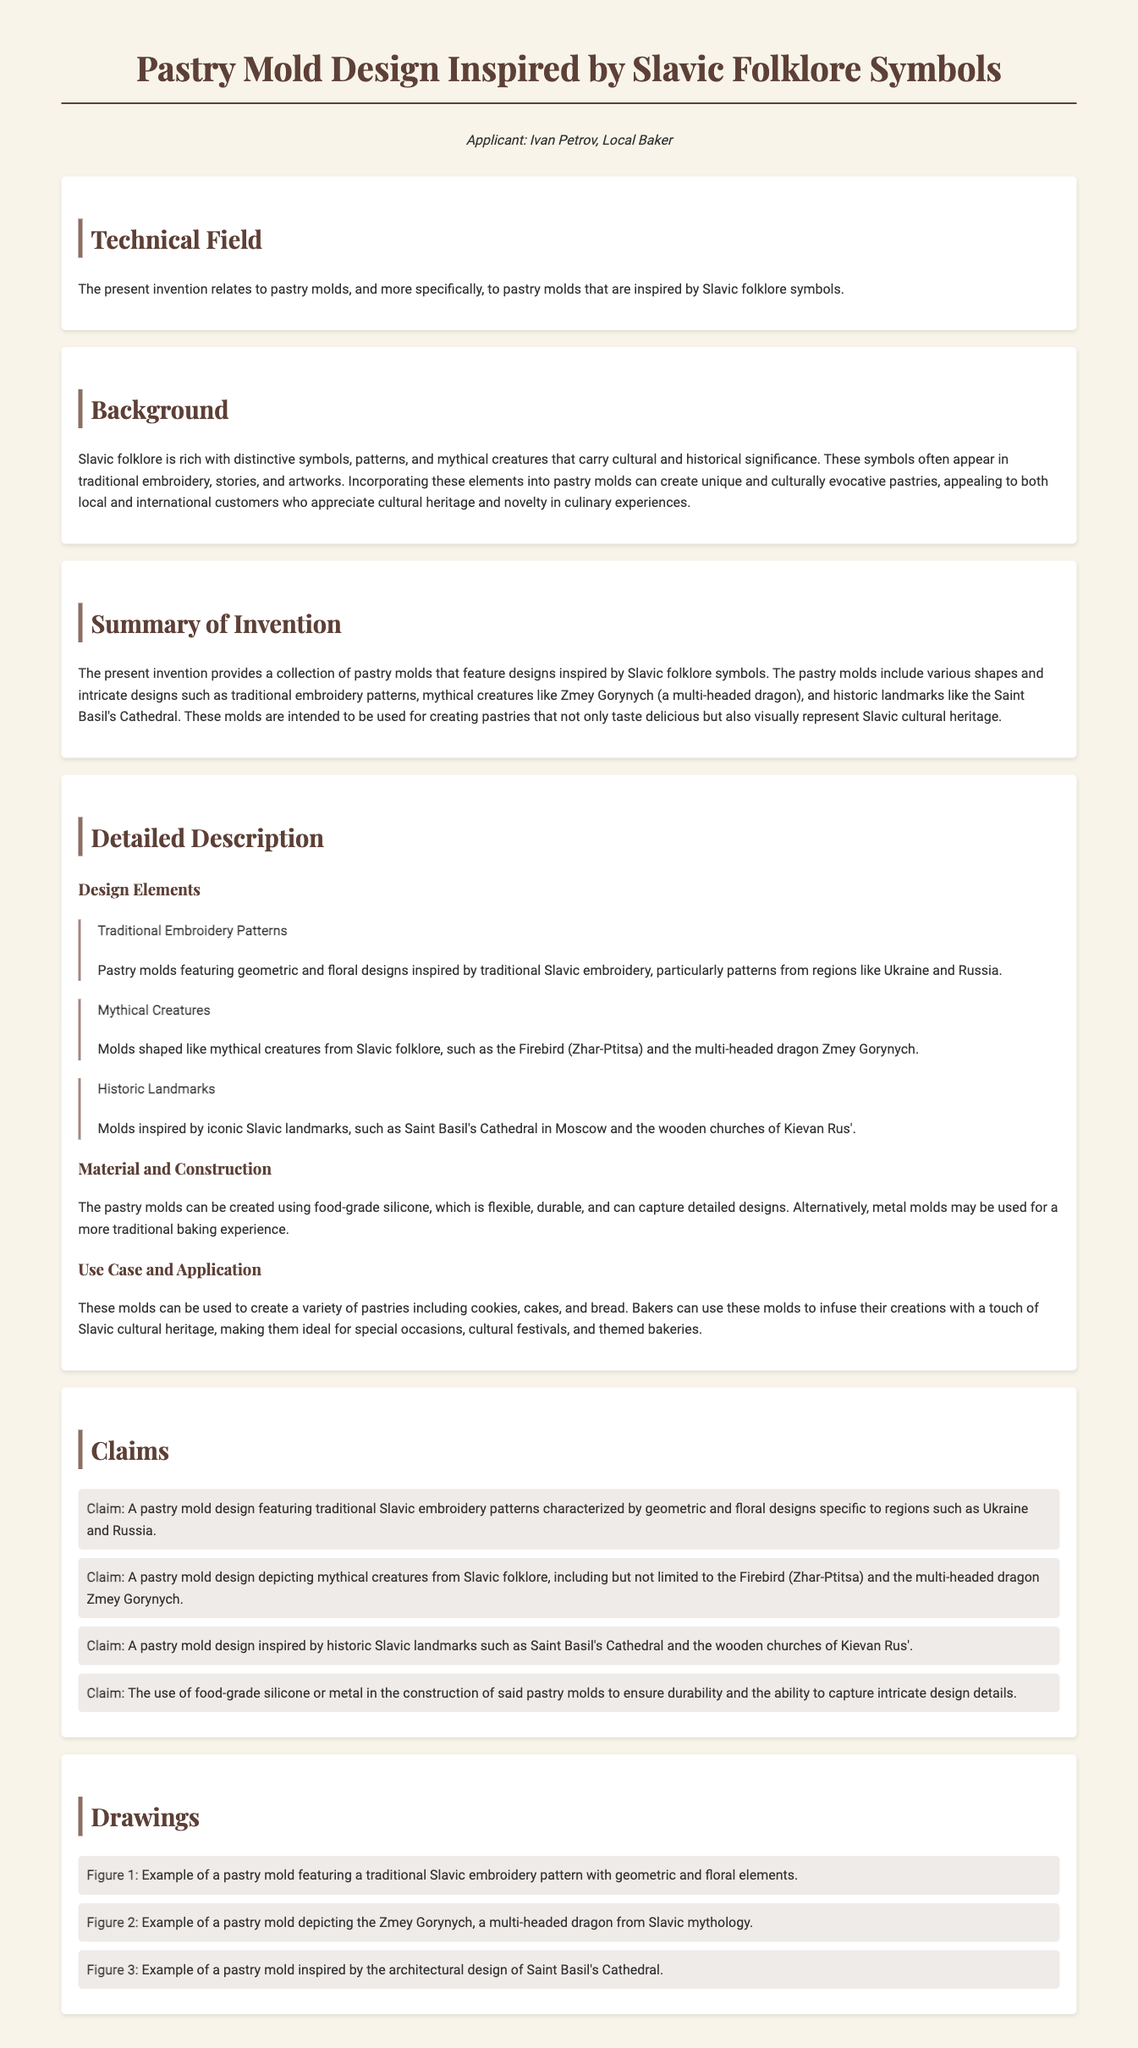What is the applicant's name? The applicant's name is mentioned at the top of the document as Ivan Petrov.
Answer: Ivan Petrov What material can be used to create the pastry molds? The document specifies that food-grade silicone or metal can be used in the construction of the molds.
Answer: food-grade silicone or metal What mythical creature is mentioned in the claims? The claims reference the Firebird (Zhar-Ptitsa) as a mythical creature from Slavic folklore.
Answer: Firebird (Zhar-Ptitsa) What is the primary purpose of the pastry molds described in this application? The primary purpose is to create pastries that visually represent Slavic cultural heritage while also being delicious.
Answer: create pastries Which historic landmark is cited in the document? The document mentions Saint Basil's Cathedral as an iconic Slavic landmark inspiring the molds.
Answer: Saint Basil's Cathedral How many claims are presented in the document? The number of claims listed in the section is four.
Answer: four What is the first design element discussed in the detailed description? The first design element mentioned is traditional embroidery patterns.
Answer: traditional embroidery patterns What type of document is this? The type of document is indicated in the title and opening section as a patent application.
Answer: patent application 